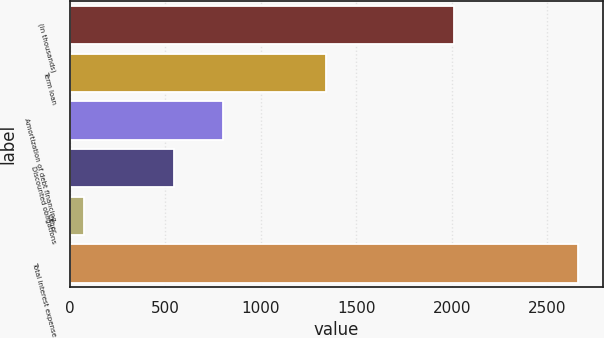Convert chart to OTSL. <chart><loc_0><loc_0><loc_500><loc_500><bar_chart><fcel>(in thousands)<fcel>Term loan<fcel>Amortization of debt financing<fcel>Discounted obligations<fcel>Other<fcel>Total interest expense<nl><fcel>2012<fcel>1342<fcel>804.6<fcel>546<fcel>75<fcel>2661<nl></chart> 